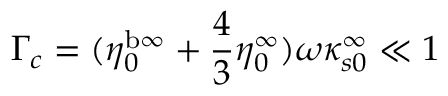Convert formula to latex. <formula><loc_0><loc_0><loc_500><loc_500>\Gamma _ { c } = ( \eta _ { 0 } ^ { b \infty } + \frac { 4 } { 3 } \eta _ { 0 } ^ { \infty } ) \omega \kappa _ { s 0 } ^ { \infty } \ll 1</formula> 